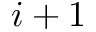Convert formula to latex. <formula><loc_0><loc_0><loc_500><loc_500>i + 1</formula> 